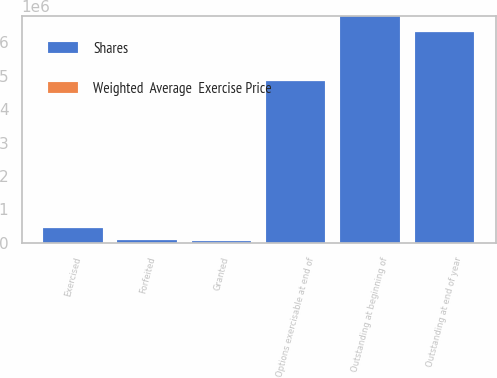<chart> <loc_0><loc_0><loc_500><loc_500><stacked_bar_chart><ecel><fcel>Outstanding at beginning of<fcel>Granted<fcel>Exercised<fcel>Forfeited<fcel>Outstanding at end of year<fcel>Options exercisable at end of<nl><fcel>Shares<fcel>6.79183e+06<fcel>42206<fcel>445916<fcel>93376<fcel>6.29474e+06<fcel>4.83512e+06<nl><fcel>Weighted  Average  Exercise Price<fcel>39.85<fcel>38.33<fcel>26.62<fcel>48.83<fcel>40.66<fcel>36.31<nl></chart> 